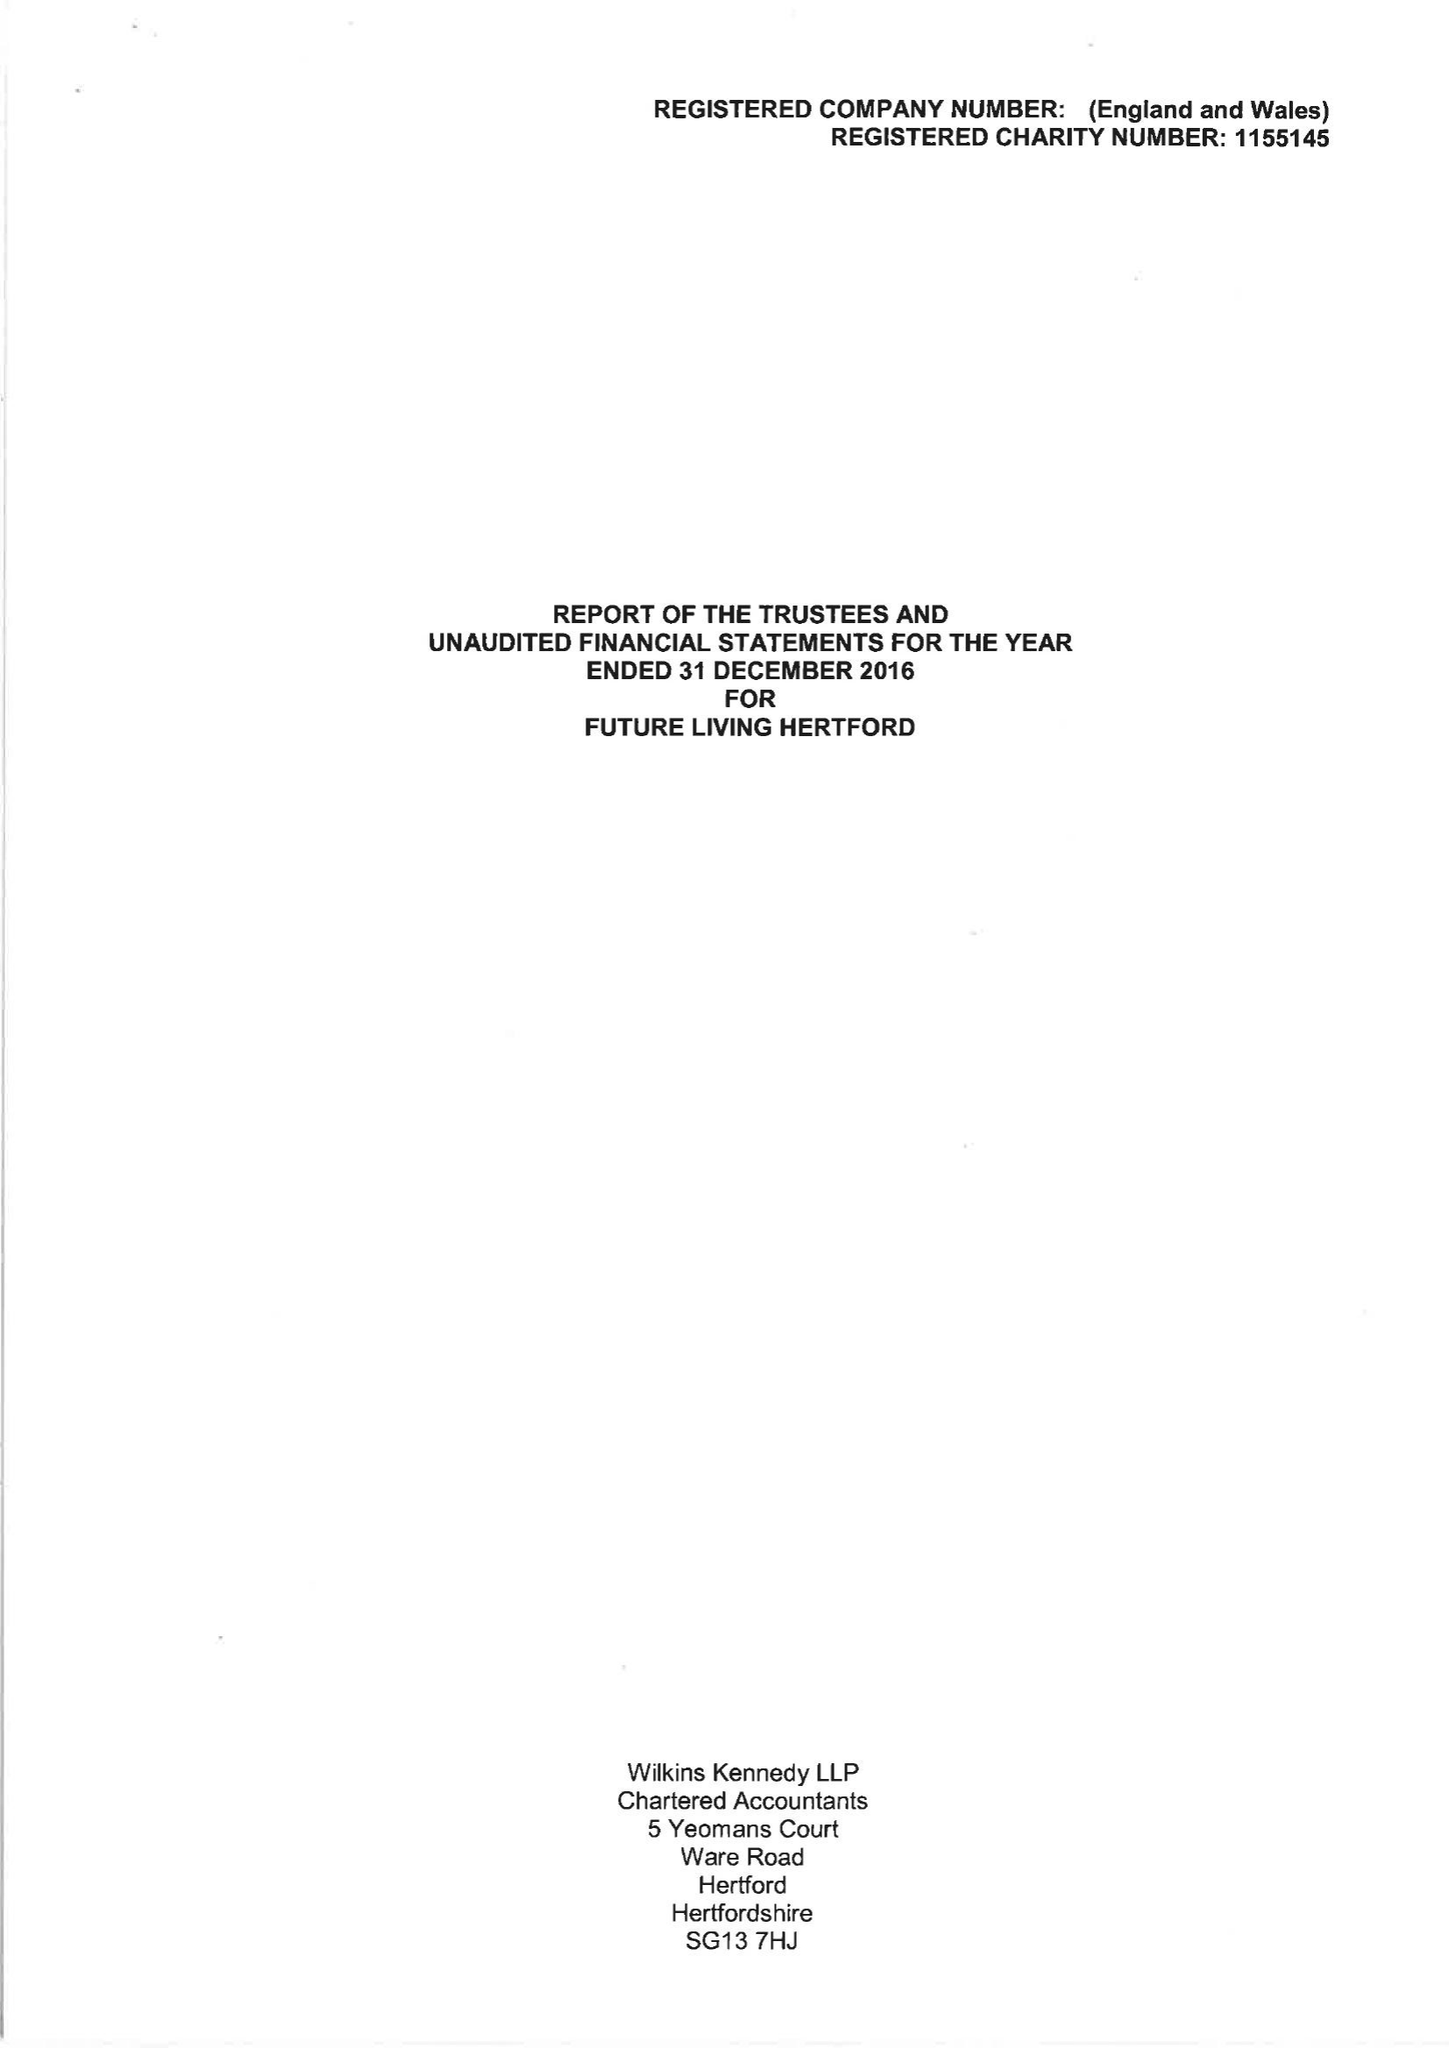What is the value for the charity_name?
Answer the question using a single word or phrase. Future Living Hertford 